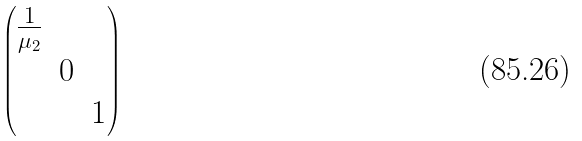<formula> <loc_0><loc_0><loc_500><loc_500>\begin{pmatrix} \frac { 1 } { \mu _ { 2 } } & & \\ & 0 & \\ & & 1 \end{pmatrix}</formula> 